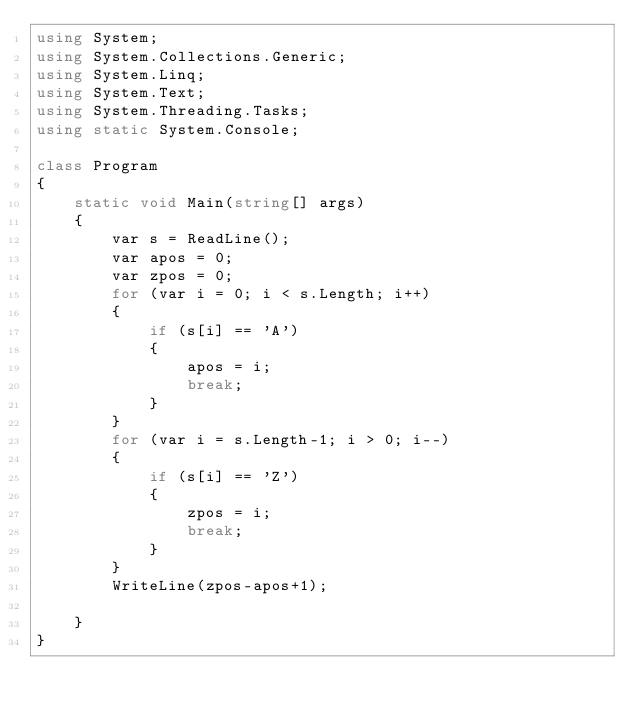<code> <loc_0><loc_0><loc_500><loc_500><_C#_>using System;
using System.Collections.Generic;
using System.Linq;
using System.Text;
using System.Threading.Tasks;
using static System.Console;

class Program
{
    static void Main(string[] args)
    {
        var s = ReadLine();
        var apos = 0;
        var zpos = 0;
        for (var i = 0; i < s.Length; i++)
        {
            if (s[i] == 'A')
            {
                apos = i;
                break;
            }
        }
        for (var i = s.Length-1; i > 0; i--)
        {
            if (s[i] == 'Z')
            {
                zpos = i;
                break;
            }
        }
        WriteLine(zpos-apos+1);
    
    }
}

</code> 